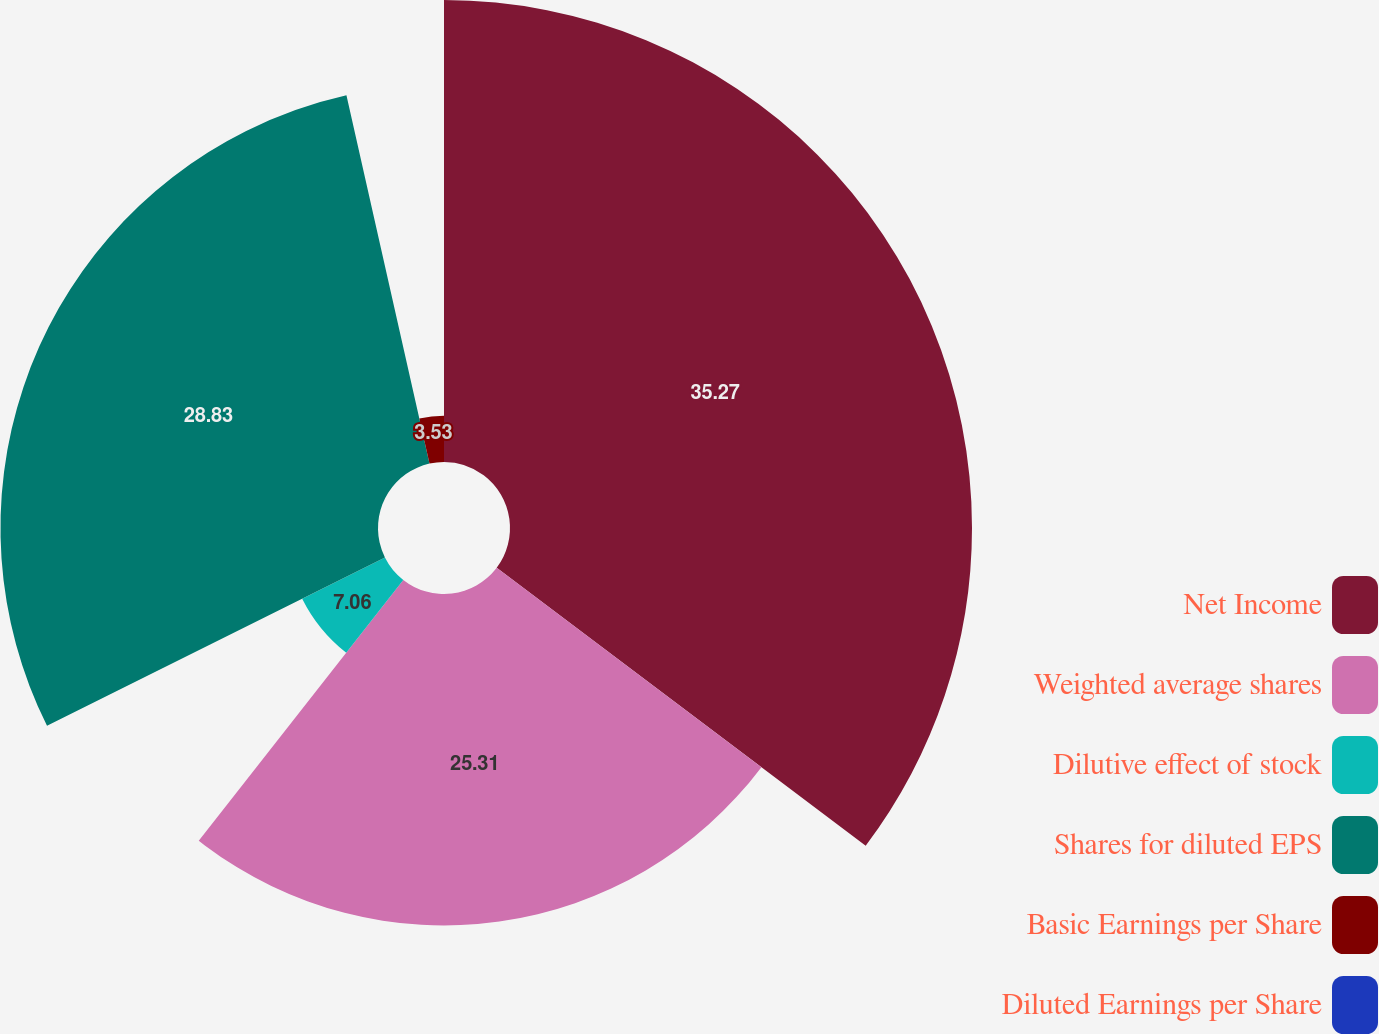Convert chart to OTSL. <chart><loc_0><loc_0><loc_500><loc_500><pie_chart><fcel>Net Income<fcel>Weighted average shares<fcel>Dilutive effect of stock<fcel>Shares for diluted EPS<fcel>Basic Earnings per Share<fcel>Diluted Earnings per Share<nl><fcel>35.28%<fcel>25.31%<fcel>7.06%<fcel>28.83%<fcel>3.53%<fcel>0.0%<nl></chart> 